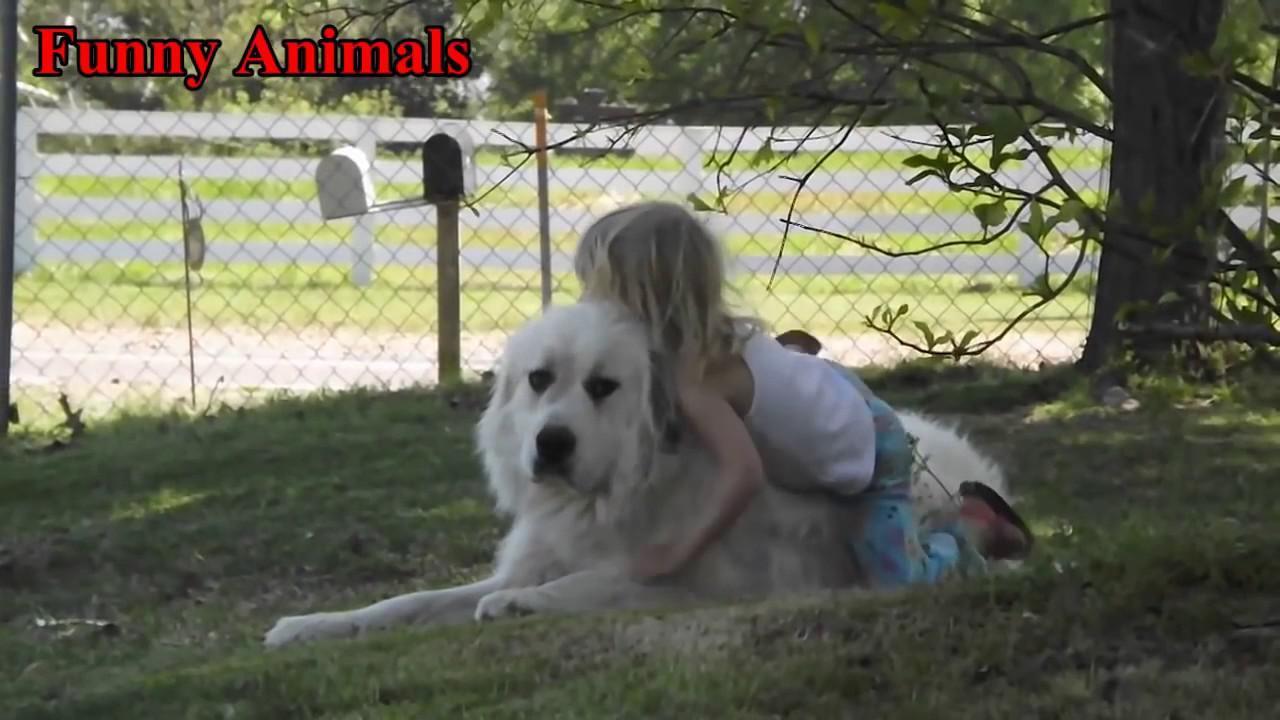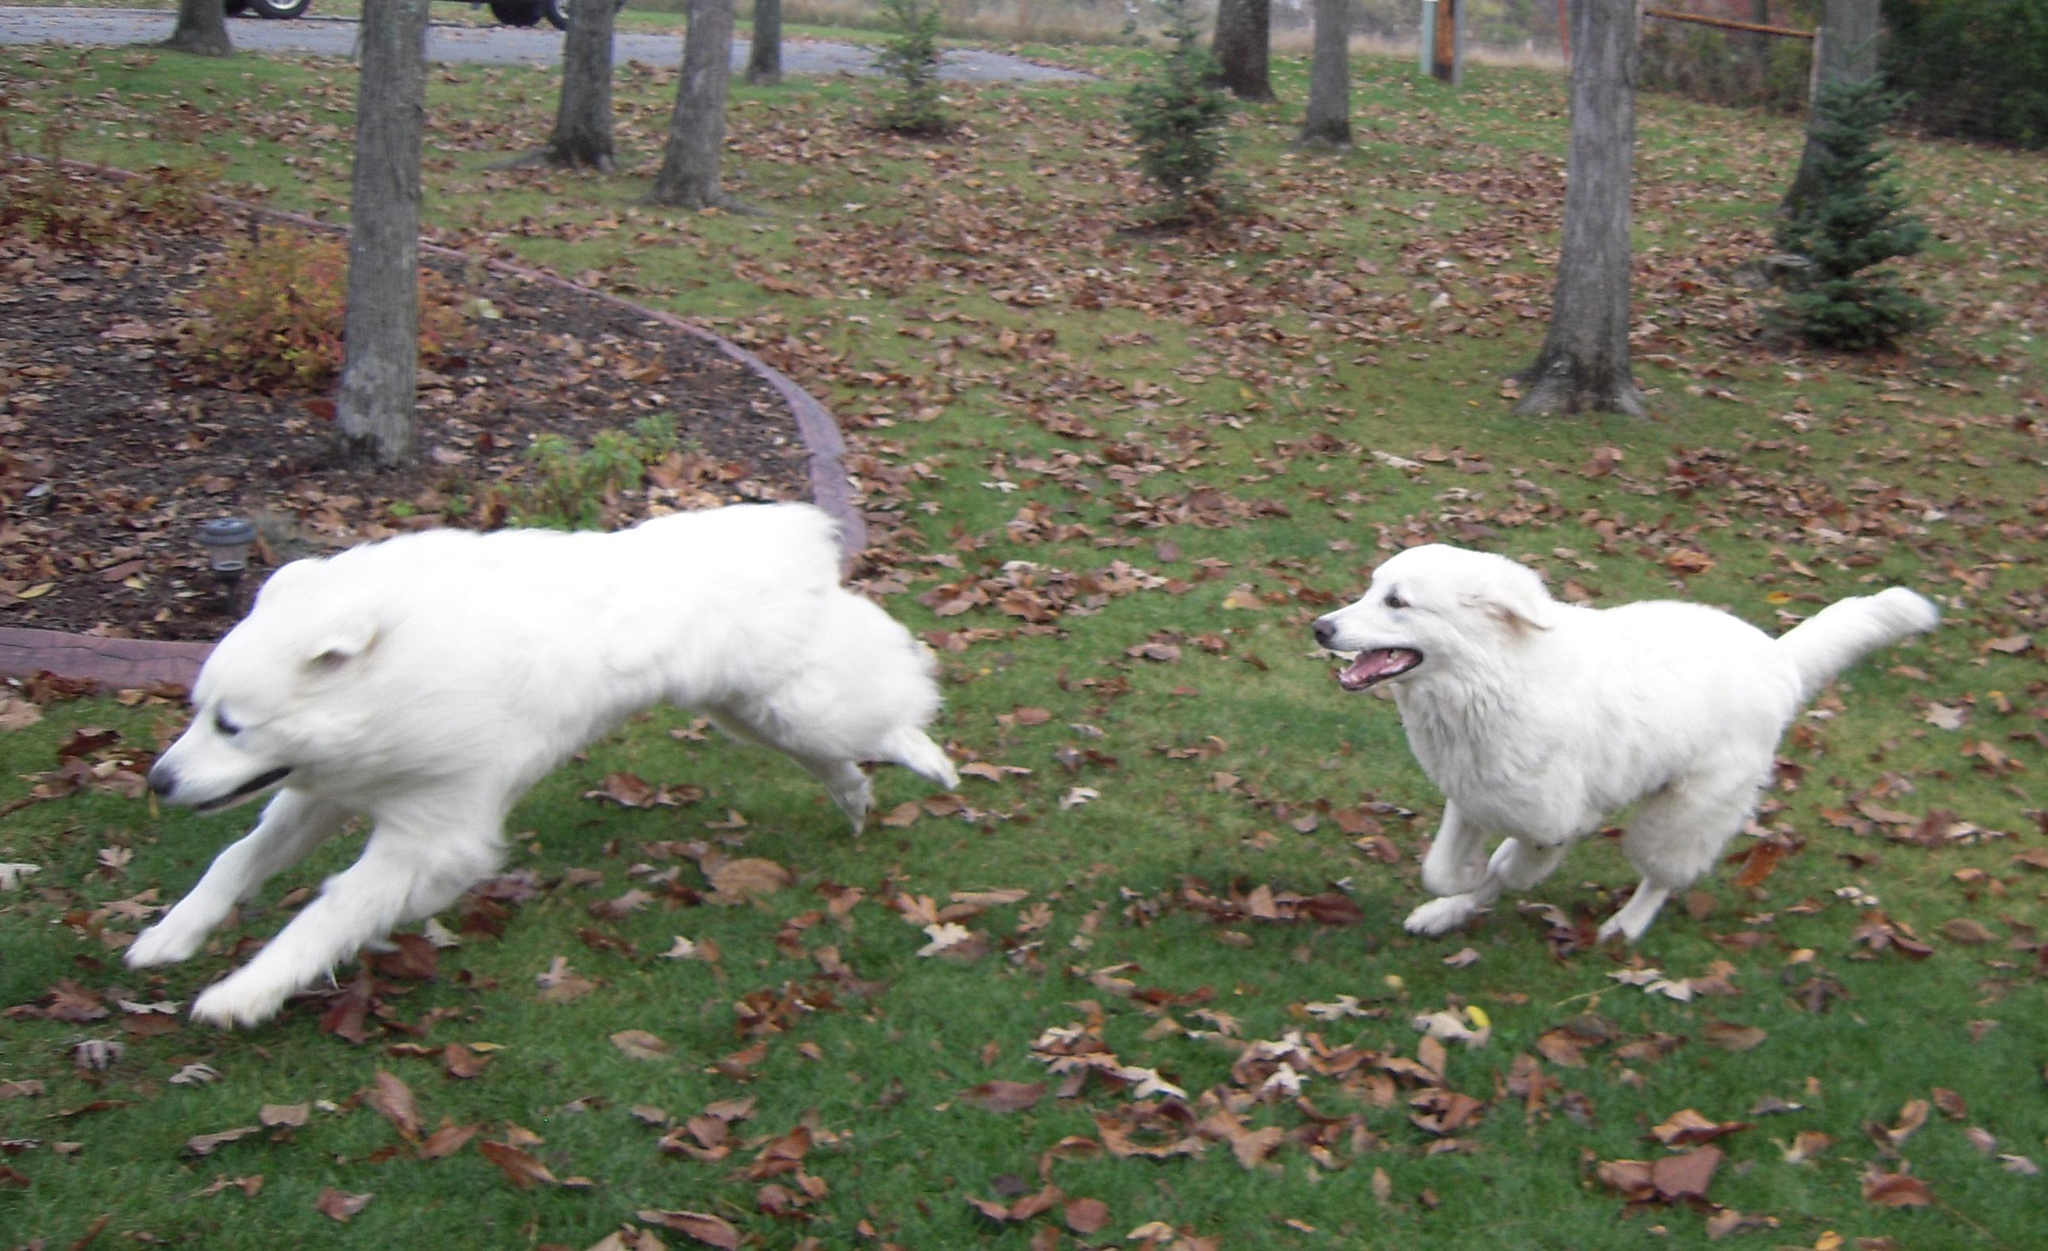The first image is the image on the left, the second image is the image on the right. Analyze the images presented: Is the assertion "An image shows a standing dog with something furry in its mouth." valid? Answer yes or no. No. 